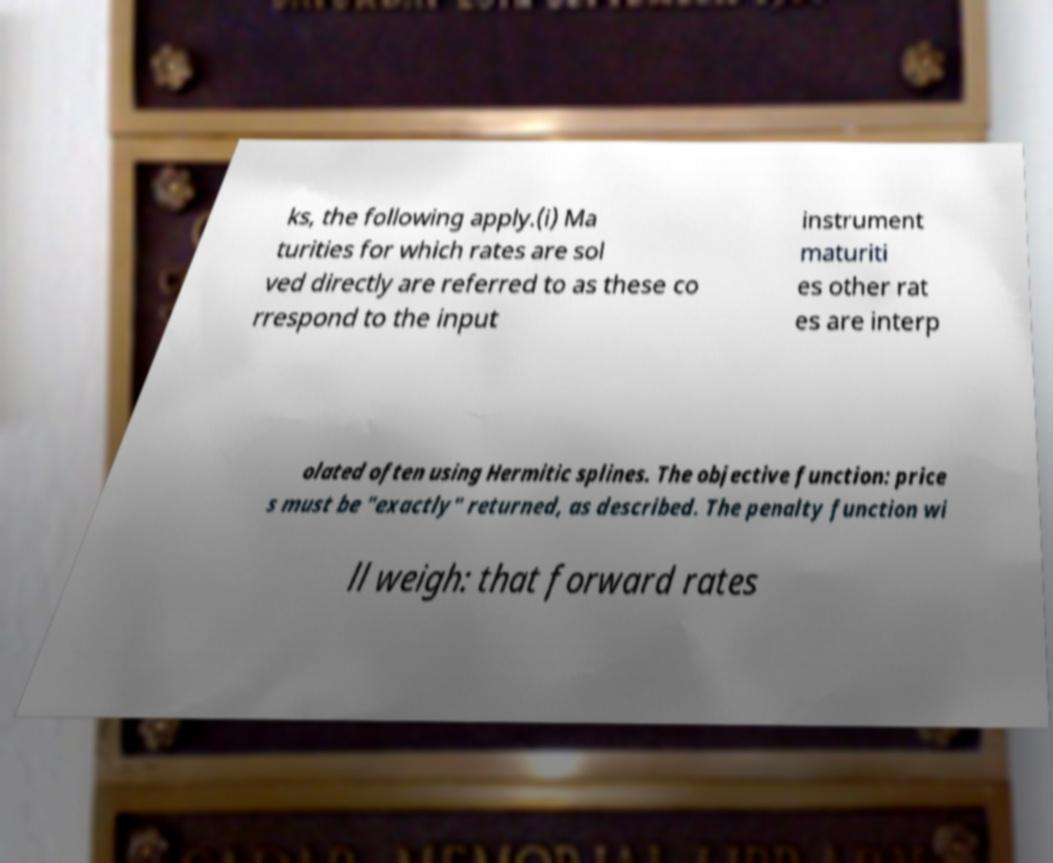Can you accurately transcribe the text from the provided image for me? ks, the following apply.(i) Ma turities for which rates are sol ved directly are referred to as these co rrespond to the input instrument maturiti es other rat es are interp olated often using Hermitic splines. The objective function: price s must be "exactly" returned, as described. The penalty function wi ll weigh: that forward rates 